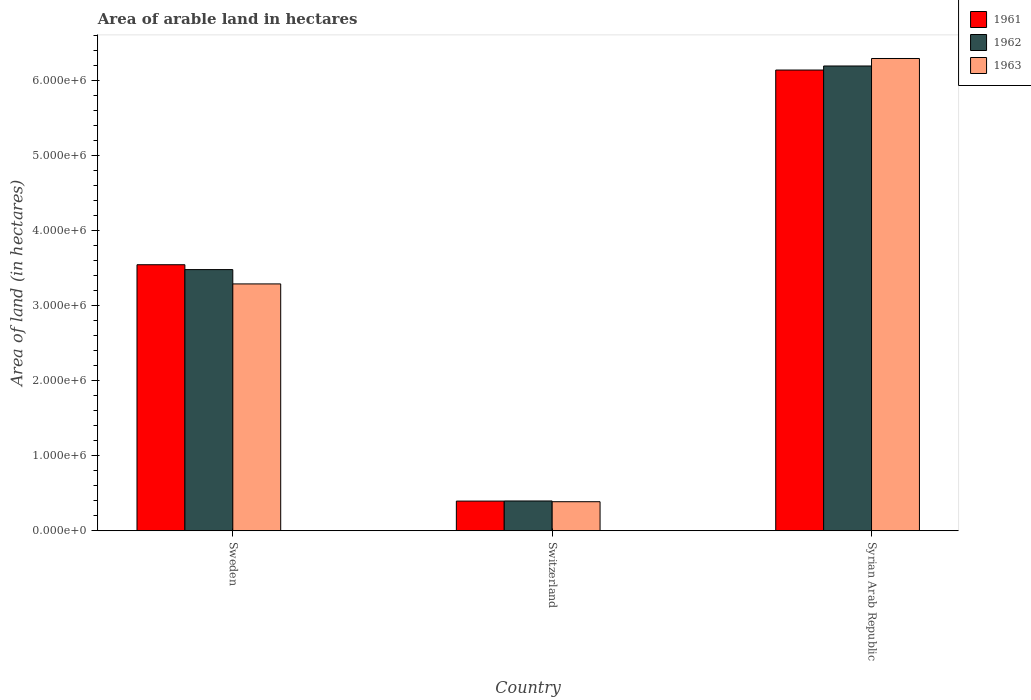Are the number of bars on each tick of the X-axis equal?
Your answer should be very brief. Yes. How many bars are there on the 3rd tick from the left?
Offer a very short reply. 3. How many bars are there on the 3rd tick from the right?
Your answer should be compact. 3. In how many cases, is the number of bars for a given country not equal to the number of legend labels?
Your response must be concise. 0. What is the total arable land in 1961 in Sweden?
Keep it short and to the point. 3.55e+06. Across all countries, what is the maximum total arable land in 1961?
Provide a succinct answer. 6.15e+06. Across all countries, what is the minimum total arable land in 1962?
Make the answer very short. 3.98e+05. In which country was the total arable land in 1962 maximum?
Make the answer very short. Syrian Arab Republic. In which country was the total arable land in 1962 minimum?
Give a very brief answer. Switzerland. What is the total total arable land in 1961 in the graph?
Provide a succinct answer. 1.01e+07. What is the difference between the total arable land in 1961 in Switzerland and that in Syrian Arab Republic?
Your answer should be very brief. -5.75e+06. What is the difference between the total arable land in 1961 in Sweden and the total arable land in 1963 in Syrian Arab Republic?
Ensure brevity in your answer.  -2.75e+06. What is the average total arable land in 1963 per country?
Provide a short and direct response. 3.33e+06. What is the difference between the total arable land of/in 1962 and total arable land of/in 1963 in Sweden?
Give a very brief answer. 1.91e+05. In how many countries, is the total arable land in 1962 greater than 6000000 hectares?
Your response must be concise. 1. What is the ratio of the total arable land in 1962 in Switzerland to that in Syrian Arab Republic?
Give a very brief answer. 0.06. Is the difference between the total arable land in 1962 in Sweden and Syrian Arab Republic greater than the difference between the total arable land in 1963 in Sweden and Syrian Arab Republic?
Give a very brief answer. Yes. What is the difference between the highest and the second highest total arable land in 1963?
Your answer should be compact. 3.01e+06. What is the difference between the highest and the lowest total arable land in 1962?
Offer a very short reply. 5.80e+06. In how many countries, is the total arable land in 1963 greater than the average total arable land in 1963 taken over all countries?
Offer a terse response. 1. What does the 2nd bar from the left in Switzerland represents?
Keep it short and to the point. 1962. What does the 2nd bar from the right in Sweden represents?
Your response must be concise. 1962. Are all the bars in the graph horizontal?
Your answer should be very brief. No. How many countries are there in the graph?
Offer a terse response. 3. Are the values on the major ticks of Y-axis written in scientific E-notation?
Ensure brevity in your answer.  Yes. Does the graph contain any zero values?
Offer a very short reply. No. Does the graph contain grids?
Provide a succinct answer. No. Where does the legend appear in the graph?
Your answer should be very brief. Top right. How many legend labels are there?
Ensure brevity in your answer.  3. What is the title of the graph?
Provide a short and direct response. Area of arable land in hectares. Does "2015" appear as one of the legend labels in the graph?
Provide a short and direct response. No. What is the label or title of the X-axis?
Keep it short and to the point. Country. What is the label or title of the Y-axis?
Offer a very short reply. Area of land (in hectares). What is the Area of land (in hectares) in 1961 in Sweden?
Offer a terse response. 3.55e+06. What is the Area of land (in hectares) in 1962 in Sweden?
Offer a terse response. 3.48e+06. What is the Area of land (in hectares) in 1963 in Sweden?
Your answer should be very brief. 3.29e+06. What is the Area of land (in hectares) in 1961 in Switzerland?
Your response must be concise. 3.96e+05. What is the Area of land (in hectares) in 1962 in Switzerland?
Keep it short and to the point. 3.98e+05. What is the Area of land (in hectares) of 1963 in Switzerland?
Keep it short and to the point. 3.88e+05. What is the Area of land (in hectares) in 1961 in Syrian Arab Republic?
Your answer should be very brief. 6.15e+06. What is the Area of land (in hectares) in 1962 in Syrian Arab Republic?
Provide a succinct answer. 6.20e+06. What is the Area of land (in hectares) of 1963 in Syrian Arab Republic?
Your response must be concise. 6.30e+06. Across all countries, what is the maximum Area of land (in hectares) in 1961?
Offer a terse response. 6.15e+06. Across all countries, what is the maximum Area of land (in hectares) in 1962?
Keep it short and to the point. 6.20e+06. Across all countries, what is the maximum Area of land (in hectares) of 1963?
Keep it short and to the point. 6.30e+06. Across all countries, what is the minimum Area of land (in hectares) of 1961?
Ensure brevity in your answer.  3.96e+05. Across all countries, what is the minimum Area of land (in hectares) in 1962?
Provide a short and direct response. 3.98e+05. Across all countries, what is the minimum Area of land (in hectares) of 1963?
Offer a terse response. 3.88e+05. What is the total Area of land (in hectares) of 1961 in the graph?
Offer a very short reply. 1.01e+07. What is the total Area of land (in hectares) of 1962 in the graph?
Keep it short and to the point. 1.01e+07. What is the total Area of land (in hectares) of 1963 in the graph?
Your response must be concise. 9.98e+06. What is the difference between the Area of land (in hectares) in 1961 in Sweden and that in Switzerland?
Offer a terse response. 3.15e+06. What is the difference between the Area of land (in hectares) of 1962 in Sweden and that in Switzerland?
Your response must be concise. 3.09e+06. What is the difference between the Area of land (in hectares) of 1963 in Sweden and that in Switzerland?
Your answer should be compact. 2.91e+06. What is the difference between the Area of land (in hectares) of 1961 in Sweden and that in Syrian Arab Republic?
Provide a short and direct response. -2.60e+06. What is the difference between the Area of land (in hectares) of 1962 in Sweden and that in Syrian Arab Republic?
Your answer should be compact. -2.72e+06. What is the difference between the Area of land (in hectares) in 1963 in Sweden and that in Syrian Arab Republic?
Your response must be concise. -3.01e+06. What is the difference between the Area of land (in hectares) in 1961 in Switzerland and that in Syrian Arab Republic?
Keep it short and to the point. -5.75e+06. What is the difference between the Area of land (in hectares) of 1962 in Switzerland and that in Syrian Arab Republic?
Your response must be concise. -5.80e+06. What is the difference between the Area of land (in hectares) of 1963 in Switzerland and that in Syrian Arab Republic?
Provide a succinct answer. -5.91e+06. What is the difference between the Area of land (in hectares) in 1961 in Sweden and the Area of land (in hectares) in 1962 in Switzerland?
Offer a very short reply. 3.15e+06. What is the difference between the Area of land (in hectares) in 1961 in Sweden and the Area of land (in hectares) in 1963 in Switzerland?
Ensure brevity in your answer.  3.16e+06. What is the difference between the Area of land (in hectares) of 1962 in Sweden and the Area of land (in hectares) of 1963 in Switzerland?
Keep it short and to the point. 3.10e+06. What is the difference between the Area of land (in hectares) of 1961 in Sweden and the Area of land (in hectares) of 1962 in Syrian Arab Republic?
Offer a very short reply. -2.65e+06. What is the difference between the Area of land (in hectares) in 1961 in Sweden and the Area of land (in hectares) in 1963 in Syrian Arab Republic?
Your answer should be compact. -2.75e+06. What is the difference between the Area of land (in hectares) of 1962 in Sweden and the Area of land (in hectares) of 1963 in Syrian Arab Republic?
Your response must be concise. -2.82e+06. What is the difference between the Area of land (in hectares) of 1961 in Switzerland and the Area of land (in hectares) of 1962 in Syrian Arab Republic?
Your answer should be compact. -5.80e+06. What is the difference between the Area of land (in hectares) of 1961 in Switzerland and the Area of land (in hectares) of 1963 in Syrian Arab Republic?
Offer a terse response. -5.90e+06. What is the difference between the Area of land (in hectares) in 1962 in Switzerland and the Area of land (in hectares) in 1963 in Syrian Arab Republic?
Your answer should be very brief. -5.90e+06. What is the average Area of land (in hectares) of 1961 per country?
Your answer should be very brief. 3.36e+06. What is the average Area of land (in hectares) of 1962 per country?
Your answer should be very brief. 3.36e+06. What is the average Area of land (in hectares) in 1963 per country?
Provide a succinct answer. 3.33e+06. What is the difference between the Area of land (in hectares) of 1961 and Area of land (in hectares) of 1962 in Sweden?
Your response must be concise. 6.50e+04. What is the difference between the Area of land (in hectares) of 1961 and Area of land (in hectares) of 1963 in Sweden?
Make the answer very short. 2.56e+05. What is the difference between the Area of land (in hectares) of 1962 and Area of land (in hectares) of 1963 in Sweden?
Your response must be concise. 1.91e+05. What is the difference between the Area of land (in hectares) of 1961 and Area of land (in hectares) of 1962 in Switzerland?
Your answer should be compact. -1600. What is the difference between the Area of land (in hectares) in 1961 and Area of land (in hectares) in 1963 in Switzerland?
Give a very brief answer. 8200. What is the difference between the Area of land (in hectares) in 1962 and Area of land (in hectares) in 1963 in Switzerland?
Give a very brief answer. 9800. What is the difference between the Area of land (in hectares) of 1961 and Area of land (in hectares) of 1962 in Syrian Arab Republic?
Your response must be concise. -5.40e+04. What is the difference between the Area of land (in hectares) of 1961 and Area of land (in hectares) of 1963 in Syrian Arab Republic?
Your response must be concise. -1.54e+05. What is the difference between the Area of land (in hectares) of 1962 and Area of land (in hectares) of 1963 in Syrian Arab Republic?
Make the answer very short. -1.00e+05. What is the ratio of the Area of land (in hectares) of 1961 in Sweden to that in Switzerland?
Ensure brevity in your answer.  8.96. What is the ratio of the Area of land (in hectares) of 1962 in Sweden to that in Switzerland?
Your answer should be compact. 8.76. What is the ratio of the Area of land (in hectares) of 1963 in Sweden to that in Switzerland?
Keep it short and to the point. 8.49. What is the ratio of the Area of land (in hectares) in 1961 in Sweden to that in Syrian Arab Republic?
Make the answer very short. 0.58. What is the ratio of the Area of land (in hectares) of 1962 in Sweden to that in Syrian Arab Republic?
Make the answer very short. 0.56. What is the ratio of the Area of land (in hectares) of 1963 in Sweden to that in Syrian Arab Republic?
Keep it short and to the point. 0.52. What is the ratio of the Area of land (in hectares) in 1961 in Switzerland to that in Syrian Arab Republic?
Your answer should be compact. 0.06. What is the ratio of the Area of land (in hectares) of 1962 in Switzerland to that in Syrian Arab Republic?
Your answer should be compact. 0.06. What is the ratio of the Area of land (in hectares) in 1963 in Switzerland to that in Syrian Arab Republic?
Provide a short and direct response. 0.06. What is the difference between the highest and the second highest Area of land (in hectares) of 1961?
Your answer should be very brief. 2.60e+06. What is the difference between the highest and the second highest Area of land (in hectares) of 1962?
Your answer should be compact. 2.72e+06. What is the difference between the highest and the second highest Area of land (in hectares) in 1963?
Ensure brevity in your answer.  3.01e+06. What is the difference between the highest and the lowest Area of land (in hectares) of 1961?
Your response must be concise. 5.75e+06. What is the difference between the highest and the lowest Area of land (in hectares) of 1962?
Your response must be concise. 5.80e+06. What is the difference between the highest and the lowest Area of land (in hectares) of 1963?
Ensure brevity in your answer.  5.91e+06. 